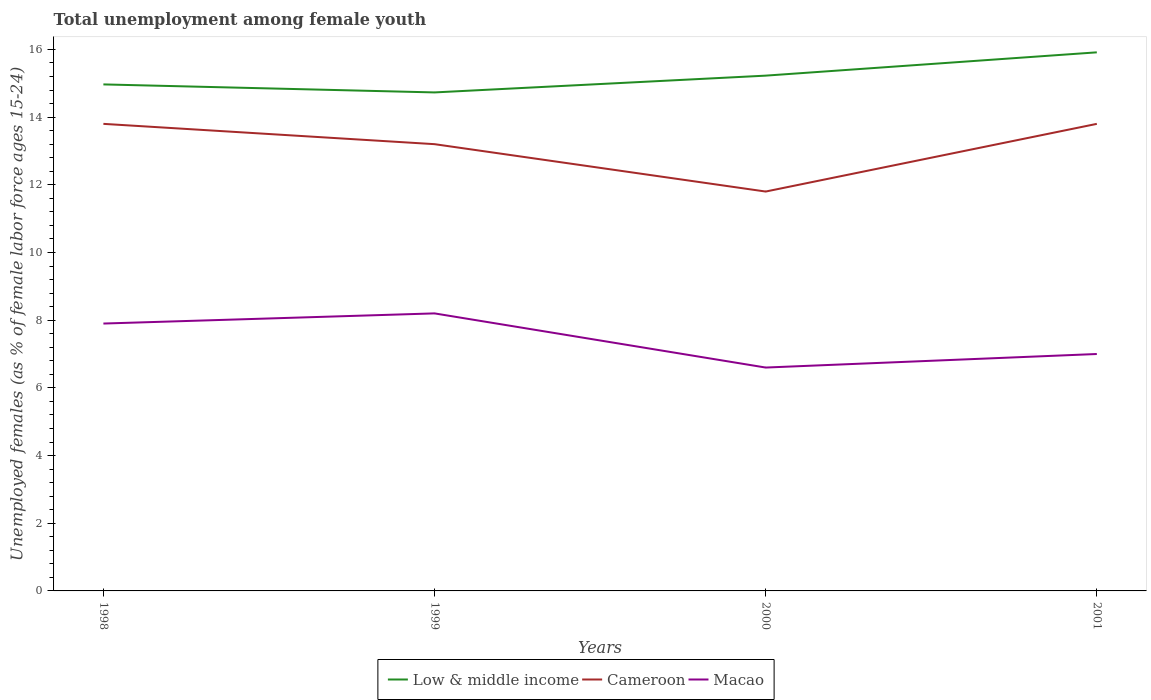Across all years, what is the maximum percentage of unemployed females in in Low & middle income?
Offer a terse response. 14.73. What is the total percentage of unemployed females in in Low & middle income in the graph?
Provide a succinct answer. -0.5. What is the difference between the highest and the second highest percentage of unemployed females in in Cameroon?
Ensure brevity in your answer.  2. How many lines are there?
Give a very brief answer. 3. How many years are there in the graph?
Make the answer very short. 4. What is the difference between two consecutive major ticks on the Y-axis?
Provide a succinct answer. 2. Does the graph contain any zero values?
Your response must be concise. No. Does the graph contain grids?
Offer a very short reply. No. Where does the legend appear in the graph?
Keep it short and to the point. Bottom center. How many legend labels are there?
Keep it short and to the point. 3. What is the title of the graph?
Provide a succinct answer. Total unemployment among female youth. Does "Sint Maarten (Dutch part)" appear as one of the legend labels in the graph?
Offer a very short reply. No. What is the label or title of the X-axis?
Provide a short and direct response. Years. What is the label or title of the Y-axis?
Your answer should be compact. Unemployed females (as % of female labor force ages 15-24). What is the Unemployed females (as % of female labor force ages 15-24) in Low & middle income in 1998?
Give a very brief answer. 14.97. What is the Unemployed females (as % of female labor force ages 15-24) in Cameroon in 1998?
Make the answer very short. 13.8. What is the Unemployed females (as % of female labor force ages 15-24) of Macao in 1998?
Offer a very short reply. 7.9. What is the Unemployed females (as % of female labor force ages 15-24) in Low & middle income in 1999?
Offer a terse response. 14.73. What is the Unemployed females (as % of female labor force ages 15-24) of Cameroon in 1999?
Your answer should be compact. 13.2. What is the Unemployed females (as % of female labor force ages 15-24) in Macao in 1999?
Make the answer very short. 8.2. What is the Unemployed females (as % of female labor force ages 15-24) in Low & middle income in 2000?
Offer a terse response. 15.22. What is the Unemployed females (as % of female labor force ages 15-24) of Cameroon in 2000?
Give a very brief answer. 11.8. What is the Unemployed females (as % of female labor force ages 15-24) in Macao in 2000?
Make the answer very short. 6.6. What is the Unemployed females (as % of female labor force ages 15-24) of Low & middle income in 2001?
Provide a succinct answer. 15.91. What is the Unemployed females (as % of female labor force ages 15-24) in Cameroon in 2001?
Offer a very short reply. 13.8. What is the Unemployed females (as % of female labor force ages 15-24) in Macao in 2001?
Ensure brevity in your answer.  7. Across all years, what is the maximum Unemployed females (as % of female labor force ages 15-24) in Low & middle income?
Offer a terse response. 15.91. Across all years, what is the maximum Unemployed females (as % of female labor force ages 15-24) of Cameroon?
Keep it short and to the point. 13.8. Across all years, what is the maximum Unemployed females (as % of female labor force ages 15-24) in Macao?
Offer a very short reply. 8.2. Across all years, what is the minimum Unemployed females (as % of female labor force ages 15-24) of Low & middle income?
Make the answer very short. 14.73. Across all years, what is the minimum Unemployed females (as % of female labor force ages 15-24) in Cameroon?
Give a very brief answer. 11.8. Across all years, what is the minimum Unemployed females (as % of female labor force ages 15-24) in Macao?
Your answer should be compact. 6.6. What is the total Unemployed females (as % of female labor force ages 15-24) of Low & middle income in the graph?
Your answer should be compact. 60.83. What is the total Unemployed females (as % of female labor force ages 15-24) of Cameroon in the graph?
Offer a terse response. 52.6. What is the total Unemployed females (as % of female labor force ages 15-24) in Macao in the graph?
Your answer should be compact. 29.7. What is the difference between the Unemployed females (as % of female labor force ages 15-24) of Low & middle income in 1998 and that in 1999?
Make the answer very short. 0.24. What is the difference between the Unemployed females (as % of female labor force ages 15-24) in Cameroon in 1998 and that in 1999?
Ensure brevity in your answer.  0.6. What is the difference between the Unemployed females (as % of female labor force ages 15-24) in Macao in 1998 and that in 1999?
Ensure brevity in your answer.  -0.3. What is the difference between the Unemployed females (as % of female labor force ages 15-24) of Low & middle income in 1998 and that in 2000?
Keep it short and to the point. -0.26. What is the difference between the Unemployed females (as % of female labor force ages 15-24) in Cameroon in 1998 and that in 2000?
Keep it short and to the point. 2. What is the difference between the Unemployed females (as % of female labor force ages 15-24) of Low & middle income in 1998 and that in 2001?
Give a very brief answer. -0.95. What is the difference between the Unemployed females (as % of female labor force ages 15-24) of Macao in 1998 and that in 2001?
Offer a very short reply. 0.9. What is the difference between the Unemployed females (as % of female labor force ages 15-24) of Low & middle income in 1999 and that in 2000?
Provide a succinct answer. -0.5. What is the difference between the Unemployed females (as % of female labor force ages 15-24) of Macao in 1999 and that in 2000?
Make the answer very short. 1.6. What is the difference between the Unemployed females (as % of female labor force ages 15-24) in Low & middle income in 1999 and that in 2001?
Ensure brevity in your answer.  -1.18. What is the difference between the Unemployed females (as % of female labor force ages 15-24) in Cameroon in 1999 and that in 2001?
Ensure brevity in your answer.  -0.6. What is the difference between the Unemployed females (as % of female labor force ages 15-24) in Macao in 1999 and that in 2001?
Give a very brief answer. 1.2. What is the difference between the Unemployed females (as % of female labor force ages 15-24) in Low & middle income in 2000 and that in 2001?
Offer a very short reply. -0.69. What is the difference between the Unemployed females (as % of female labor force ages 15-24) of Macao in 2000 and that in 2001?
Provide a short and direct response. -0.4. What is the difference between the Unemployed females (as % of female labor force ages 15-24) of Low & middle income in 1998 and the Unemployed females (as % of female labor force ages 15-24) of Cameroon in 1999?
Make the answer very short. 1.77. What is the difference between the Unemployed females (as % of female labor force ages 15-24) in Low & middle income in 1998 and the Unemployed females (as % of female labor force ages 15-24) in Macao in 1999?
Ensure brevity in your answer.  6.77. What is the difference between the Unemployed females (as % of female labor force ages 15-24) of Cameroon in 1998 and the Unemployed females (as % of female labor force ages 15-24) of Macao in 1999?
Give a very brief answer. 5.6. What is the difference between the Unemployed females (as % of female labor force ages 15-24) in Low & middle income in 1998 and the Unemployed females (as % of female labor force ages 15-24) in Cameroon in 2000?
Provide a short and direct response. 3.17. What is the difference between the Unemployed females (as % of female labor force ages 15-24) in Low & middle income in 1998 and the Unemployed females (as % of female labor force ages 15-24) in Macao in 2000?
Give a very brief answer. 8.37. What is the difference between the Unemployed females (as % of female labor force ages 15-24) of Low & middle income in 1998 and the Unemployed females (as % of female labor force ages 15-24) of Cameroon in 2001?
Your answer should be compact. 1.17. What is the difference between the Unemployed females (as % of female labor force ages 15-24) in Low & middle income in 1998 and the Unemployed females (as % of female labor force ages 15-24) in Macao in 2001?
Give a very brief answer. 7.97. What is the difference between the Unemployed females (as % of female labor force ages 15-24) in Low & middle income in 1999 and the Unemployed females (as % of female labor force ages 15-24) in Cameroon in 2000?
Provide a succinct answer. 2.93. What is the difference between the Unemployed females (as % of female labor force ages 15-24) in Low & middle income in 1999 and the Unemployed females (as % of female labor force ages 15-24) in Macao in 2000?
Give a very brief answer. 8.13. What is the difference between the Unemployed females (as % of female labor force ages 15-24) in Cameroon in 1999 and the Unemployed females (as % of female labor force ages 15-24) in Macao in 2000?
Your response must be concise. 6.6. What is the difference between the Unemployed females (as % of female labor force ages 15-24) of Low & middle income in 1999 and the Unemployed females (as % of female labor force ages 15-24) of Cameroon in 2001?
Your response must be concise. 0.93. What is the difference between the Unemployed females (as % of female labor force ages 15-24) of Low & middle income in 1999 and the Unemployed females (as % of female labor force ages 15-24) of Macao in 2001?
Make the answer very short. 7.73. What is the difference between the Unemployed females (as % of female labor force ages 15-24) of Cameroon in 1999 and the Unemployed females (as % of female labor force ages 15-24) of Macao in 2001?
Keep it short and to the point. 6.2. What is the difference between the Unemployed females (as % of female labor force ages 15-24) of Low & middle income in 2000 and the Unemployed females (as % of female labor force ages 15-24) of Cameroon in 2001?
Make the answer very short. 1.42. What is the difference between the Unemployed females (as % of female labor force ages 15-24) of Low & middle income in 2000 and the Unemployed females (as % of female labor force ages 15-24) of Macao in 2001?
Provide a succinct answer. 8.22. What is the average Unemployed females (as % of female labor force ages 15-24) of Low & middle income per year?
Provide a short and direct response. 15.21. What is the average Unemployed females (as % of female labor force ages 15-24) in Cameroon per year?
Provide a succinct answer. 13.15. What is the average Unemployed females (as % of female labor force ages 15-24) in Macao per year?
Your response must be concise. 7.42. In the year 1998, what is the difference between the Unemployed females (as % of female labor force ages 15-24) in Low & middle income and Unemployed females (as % of female labor force ages 15-24) in Cameroon?
Your response must be concise. 1.17. In the year 1998, what is the difference between the Unemployed females (as % of female labor force ages 15-24) in Low & middle income and Unemployed females (as % of female labor force ages 15-24) in Macao?
Your response must be concise. 7.07. In the year 1998, what is the difference between the Unemployed females (as % of female labor force ages 15-24) in Cameroon and Unemployed females (as % of female labor force ages 15-24) in Macao?
Offer a terse response. 5.9. In the year 1999, what is the difference between the Unemployed females (as % of female labor force ages 15-24) of Low & middle income and Unemployed females (as % of female labor force ages 15-24) of Cameroon?
Offer a very short reply. 1.53. In the year 1999, what is the difference between the Unemployed females (as % of female labor force ages 15-24) in Low & middle income and Unemployed females (as % of female labor force ages 15-24) in Macao?
Your answer should be compact. 6.53. In the year 2000, what is the difference between the Unemployed females (as % of female labor force ages 15-24) of Low & middle income and Unemployed females (as % of female labor force ages 15-24) of Cameroon?
Make the answer very short. 3.42. In the year 2000, what is the difference between the Unemployed females (as % of female labor force ages 15-24) in Low & middle income and Unemployed females (as % of female labor force ages 15-24) in Macao?
Provide a succinct answer. 8.62. In the year 2000, what is the difference between the Unemployed females (as % of female labor force ages 15-24) of Cameroon and Unemployed females (as % of female labor force ages 15-24) of Macao?
Your answer should be compact. 5.2. In the year 2001, what is the difference between the Unemployed females (as % of female labor force ages 15-24) of Low & middle income and Unemployed females (as % of female labor force ages 15-24) of Cameroon?
Your answer should be very brief. 2.11. In the year 2001, what is the difference between the Unemployed females (as % of female labor force ages 15-24) of Low & middle income and Unemployed females (as % of female labor force ages 15-24) of Macao?
Offer a terse response. 8.91. In the year 2001, what is the difference between the Unemployed females (as % of female labor force ages 15-24) of Cameroon and Unemployed females (as % of female labor force ages 15-24) of Macao?
Ensure brevity in your answer.  6.8. What is the ratio of the Unemployed females (as % of female labor force ages 15-24) of Low & middle income in 1998 to that in 1999?
Give a very brief answer. 1.02. What is the ratio of the Unemployed females (as % of female labor force ages 15-24) of Cameroon in 1998 to that in 1999?
Provide a short and direct response. 1.05. What is the ratio of the Unemployed females (as % of female labor force ages 15-24) in Macao in 1998 to that in 1999?
Ensure brevity in your answer.  0.96. What is the ratio of the Unemployed females (as % of female labor force ages 15-24) in Cameroon in 1998 to that in 2000?
Give a very brief answer. 1.17. What is the ratio of the Unemployed females (as % of female labor force ages 15-24) of Macao in 1998 to that in 2000?
Make the answer very short. 1.2. What is the ratio of the Unemployed females (as % of female labor force ages 15-24) of Low & middle income in 1998 to that in 2001?
Ensure brevity in your answer.  0.94. What is the ratio of the Unemployed females (as % of female labor force ages 15-24) of Macao in 1998 to that in 2001?
Your response must be concise. 1.13. What is the ratio of the Unemployed females (as % of female labor force ages 15-24) in Low & middle income in 1999 to that in 2000?
Give a very brief answer. 0.97. What is the ratio of the Unemployed females (as % of female labor force ages 15-24) of Cameroon in 1999 to that in 2000?
Offer a terse response. 1.12. What is the ratio of the Unemployed females (as % of female labor force ages 15-24) of Macao in 1999 to that in 2000?
Offer a very short reply. 1.24. What is the ratio of the Unemployed females (as % of female labor force ages 15-24) of Low & middle income in 1999 to that in 2001?
Keep it short and to the point. 0.93. What is the ratio of the Unemployed females (as % of female labor force ages 15-24) of Cameroon in 1999 to that in 2001?
Give a very brief answer. 0.96. What is the ratio of the Unemployed females (as % of female labor force ages 15-24) of Macao in 1999 to that in 2001?
Provide a succinct answer. 1.17. What is the ratio of the Unemployed females (as % of female labor force ages 15-24) of Low & middle income in 2000 to that in 2001?
Provide a short and direct response. 0.96. What is the ratio of the Unemployed females (as % of female labor force ages 15-24) in Cameroon in 2000 to that in 2001?
Your response must be concise. 0.86. What is the ratio of the Unemployed females (as % of female labor force ages 15-24) of Macao in 2000 to that in 2001?
Provide a short and direct response. 0.94. What is the difference between the highest and the second highest Unemployed females (as % of female labor force ages 15-24) of Low & middle income?
Provide a succinct answer. 0.69. What is the difference between the highest and the second highest Unemployed females (as % of female labor force ages 15-24) of Cameroon?
Give a very brief answer. 0. What is the difference between the highest and the second highest Unemployed females (as % of female labor force ages 15-24) in Macao?
Keep it short and to the point. 0.3. What is the difference between the highest and the lowest Unemployed females (as % of female labor force ages 15-24) in Low & middle income?
Offer a very short reply. 1.18. What is the difference between the highest and the lowest Unemployed females (as % of female labor force ages 15-24) in Macao?
Give a very brief answer. 1.6. 